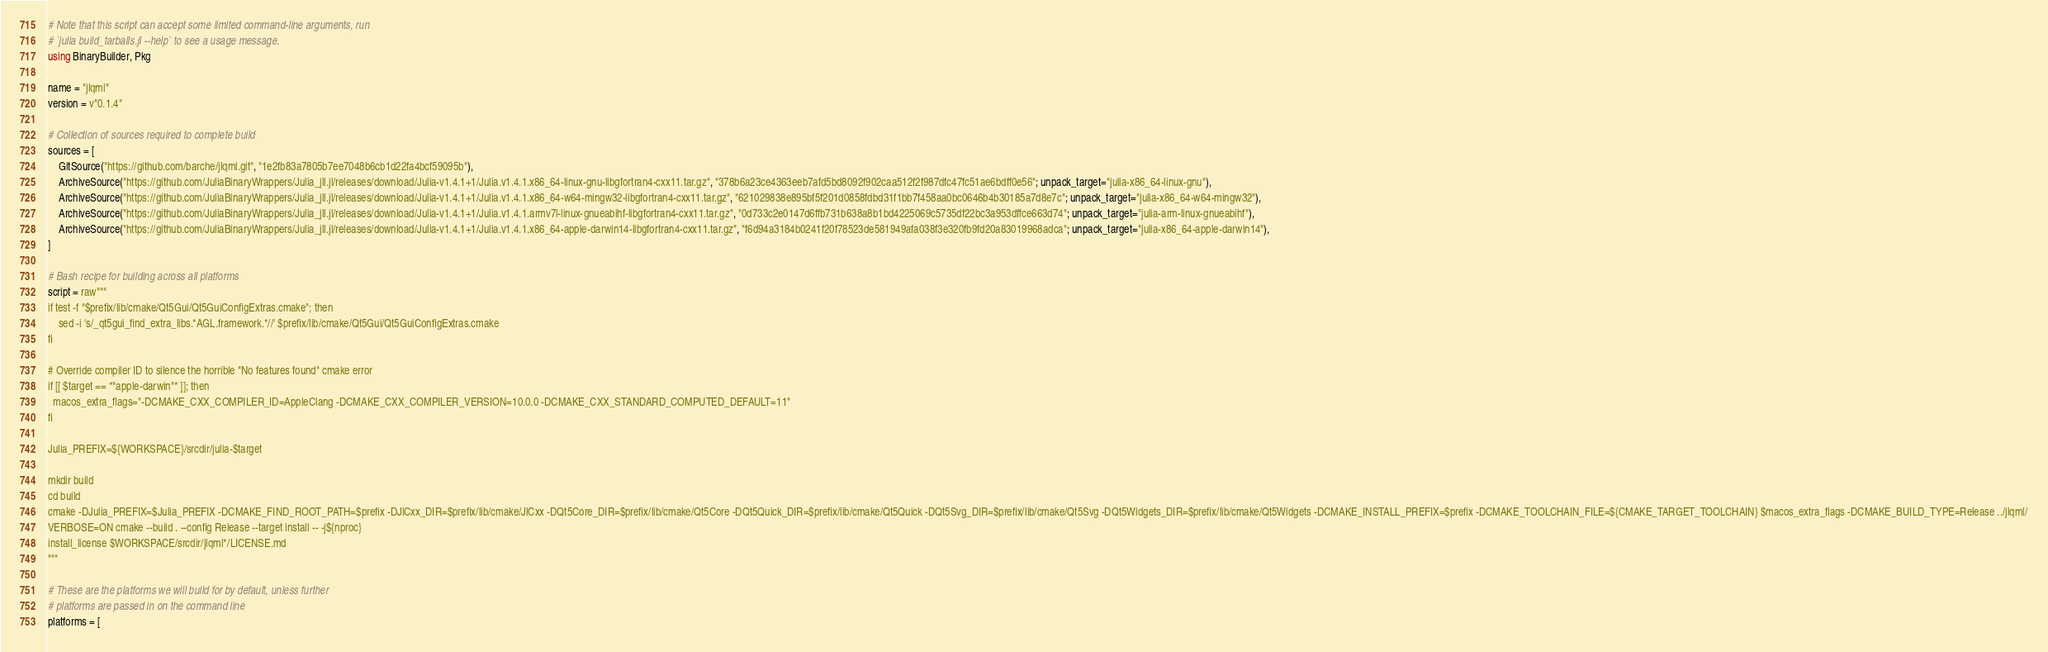<code> <loc_0><loc_0><loc_500><loc_500><_Julia_># Note that this script can accept some limited command-line arguments, run
# `julia build_tarballs.jl --help` to see a usage message.
using BinaryBuilder, Pkg

name = "jlqml"
version = v"0.1.4"

# Collection of sources required to complete build
sources = [
    GitSource("https://github.com/barche/jlqml.git", "1e2fb83a7805b7ee7048b6cb1d22fa4bcf59095b"),
    ArchiveSource("https://github.com/JuliaBinaryWrappers/Julia_jll.jl/releases/download/Julia-v1.4.1+1/Julia.v1.4.1.x86_64-linux-gnu-libgfortran4-cxx11.tar.gz", "378b6a23ce4363eeb7afd5bd8092f902caa512f2f987dfc47fc51ae6bdff0e56"; unpack_target="julia-x86_64-linux-gnu"),
    ArchiveSource("https://github.com/JuliaBinaryWrappers/Julia_jll.jl/releases/download/Julia-v1.4.1+1/Julia.v1.4.1.x86_64-w64-mingw32-libgfortran4-cxx11.tar.gz", "621029838e895bf5f201d0858fdbd31f1bb7f458aa0bc0646b4b30185a7d8e7c"; unpack_target="julia-x86_64-w64-mingw32"),
    ArchiveSource("https://github.com/JuliaBinaryWrappers/Julia_jll.jl/releases/download/Julia-v1.4.1+1/Julia.v1.4.1.armv7l-linux-gnueabihf-libgfortran4-cxx11.tar.gz", "0d733c2e0147d6ffb731b638a8b1bd4225069c5735df22bc3a953dffce663d74"; unpack_target="julia-arm-linux-gnueabihf"),
    ArchiveSource("https://github.com/JuliaBinaryWrappers/Julia_jll.jl/releases/download/Julia-v1.4.1+1/Julia.v1.4.1.x86_64-apple-darwin14-libgfortran4-cxx11.tar.gz", "f6d94a3184b0241f20f78523de581949afa038f3e320fb9fd20a83019968adca"; unpack_target="julia-x86_64-apple-darwin14"),
]

# Bash recipe for building across all platforms
script = raw"""
if test -f "$prefix/lib/cmake/Qt5Gui/Qt5GuiConfigExtras.cmake"; then
    sed -i 's/_qt5gui_find_extra_libs.*AGL.framework.*//' $prefix/lib/cmake/Qt5Gui/Qt5GuiConfigExtras.cmake
fi

# Override compiler ID to silence the horrible "No features found" cmake error
if [[ $target == *"apple-darwin"* ]]; then
  macos_extra_flags="-DCMAKE_CXX_COMPILER_ID=AppleClang -DCMAKE_CXX_COMPILER_VERSION=10.0.0 -DCMAKE_CXX_STANDARD_COMPUTED_DEFAULT=11"
fi

Julia_PREFIX=${WORKSPACE}/srcdir/julia-$target

mkdir build
cd build
cmake -DJulia_PREFIX=$Julia_PREFIX -DCMAKE_FIND_ROOT_PATH=$prefix -DJlCxx_DIR=$prefix/lib/cmake/JlCxx -DQt5Core_DIR=$prefix/lib/cmake/Qt5Core -DQt5Quick_DIR=$prefix/lib/cmake/Qt5Quick -DQt5Svg_DIR=$prefix/lib/cmake/Qt5Svg -DQt5Widgets_DIR=$prefix/lib/cmake/Qt5Widgets -DCMAKE_INSTALL_PREFIX=$prefix -DCMAKE_TOOLCHAIN_FILE=${CMAKE_TARGET_TOOLCHAIN} $macos_extra_flags -DCMAKE_BUILD_TYPE=Release ../jlqml/
VERBOSE=ON cmake --build . --config Release --target install -- -j${nproc}
install_license $WORKSPACE/srcdir/jlqml*/LICENSE.md
"""

# These are the platforms we will build for by default, unless further
# platforms are passed in on the command line
platforms = [</code> 